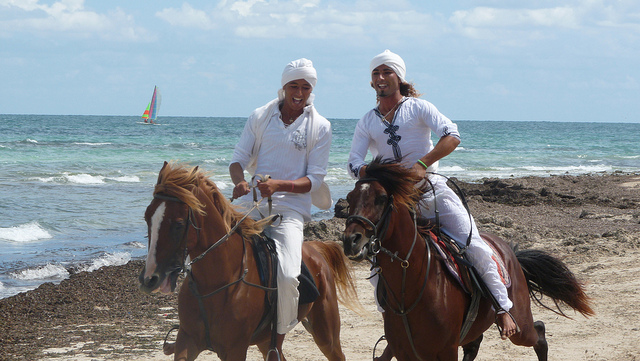What do you think they are talking about? It's likely that they are chatting about the beautiful weather and the enjoyable experience of riding horses on the beach. They could also be discussing their plans for the day or sharing stories and bonding over their shared experience. Why do you think they chose to wear white outfits? Wearing white outfits might be a practical choice for riding on the beach as white clothing can keep them cooler under the sun. It could also be for aesthetic reasons, as white outfits look striking against the backdrop of the beach and ocean, creating a visually appealing scene. 